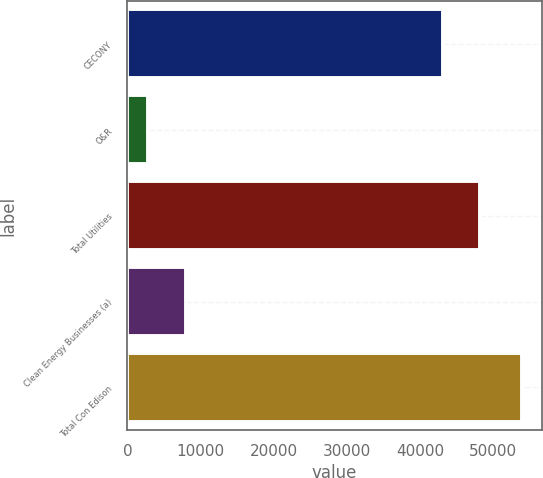<chart> <loc_0><loc_0><loc_500><loc_500><bar_chart><fcel>CECONY<fcel>O&R<fcel>Total Utilities<fcel>Clean Energy Businesses (a)<fcel>Total Con Edison<nl><fcel>43108<fcel>2892<fcel>48210.8<fcel>7994.8<fcel>53920<nl></chart> 